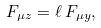Convert formula to latex. <formula><loc_0><loc_0><loc_500><loc_500>F _ { \mu z } = \ell \, F _ { \mu y } ,</formula> 